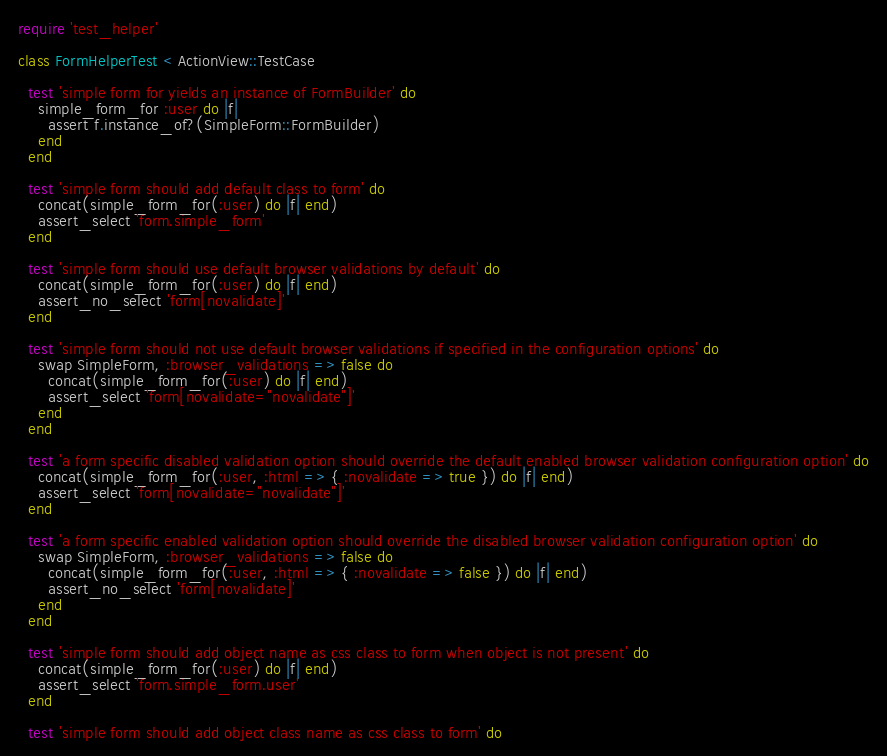Convert code to text. <code><loc_0><loc_0><loc_500><loc_500><_Ruby_>require 'test_helper'

class FormHelperTest < ActionView::TestCase

  test 'simple form for yields an instance of FormBuilder' do
    simple_form_for :user do |f|
      assert f.instance_of?(SimpleForm::FormBuilder)
    end
  end

  test 'simple form should add default class to form' do
    concat(simple_form_for(:user) do |f| end)
    assert_select 'form.simple_form'
  end

  test 'simple form should use default browser validations by default' do
    concat(simple_form_for(:user) do |f| end)
    assert_no_select 'form[novalidate]'
  end

  test 'simple form should not use default browser validations if specified in the configuration options' do
    swap SimpleForm, :browser_validations => false do
      concat(simple_form_for(:user) do |f| end)
      assert_select 'form[novalidate="novalidate"]'
    end
  end

  test 'a form specific disabled validation option should override the default enabled browser validation configuration option' do
    concat(simple_form_for(:user, :html => { :novalidate => true }) do |f| end)
    assert_select 'form[novalidate="novalidate"]'
  end

  test 'a form specific enabled validation option should override the disabled browser validation configuration option' do
    swap SimpleForm, :browser_validations => false do
      concat(simple_form_for(:user, :html => { :novalidate => false }) do |f| end)
      assert_no_select 'form[novalidate]'
    end
  end

  test 'simple form should add object name as css class to form when object is not present' do
    concat(simple_form_for(:user) do |f| end)
    assert_select 'form.simple_form.user'
  end

  test 'simple form should add object class name as css class to form' do</code> 